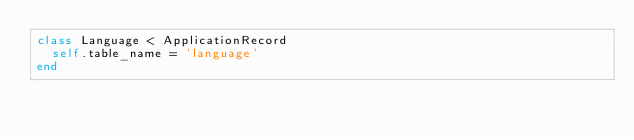Convert code to text. <code><loc_0><loc_0><loc_500><loc_500><_Ruby_>class Language < ApplicationRecord
  self.table_name = 'language'
end
</code> 